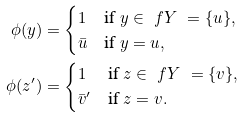<formula> <loc_0><loc_0><loc_500><loc_500>\phi ( y ) & = \begin{cases} 1 & \text {if } y \in \ f Y \ = \{ u \} , \\ \bar { u } & \text {if } y = u , \end{cases} \\ \phi ( z ^ { \prime } ) & = \begin{cases} 1 & \text {if } z \in \ f Y \ = \{ v \} , \\ \bar { v } ^ { \prime } & \text {if } z = v . \end{cases}</formula> 